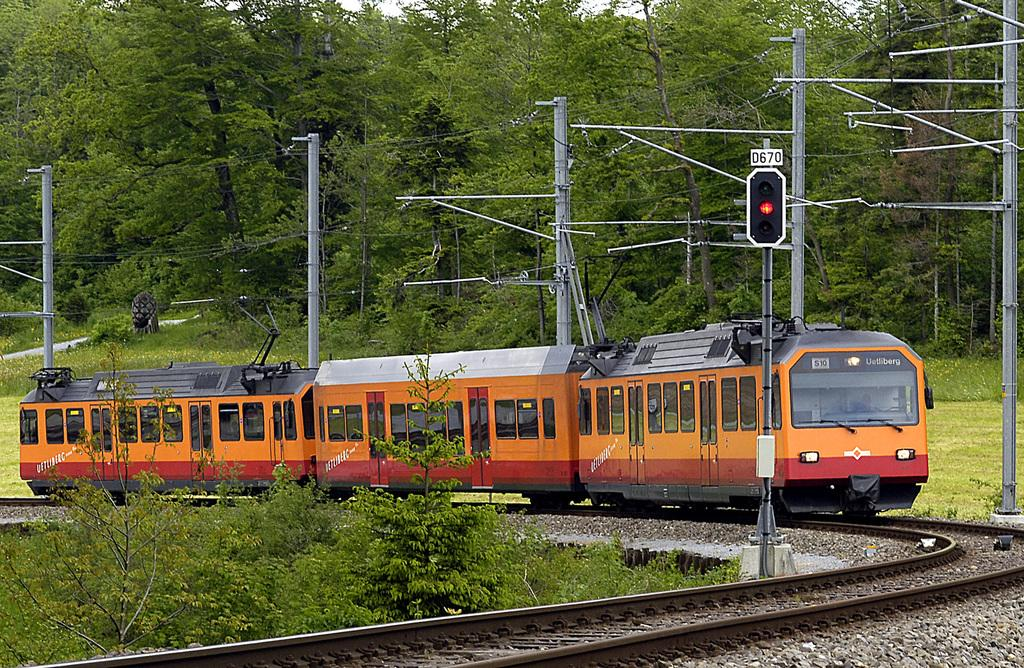What is the main subject of the image? The main subject of the image is a train on the track. What else can be seen in the image besides the train? There are electric poles and cables, trees, flowers, plants, and grass in the image. Can you describe the natural elements in the image? The image includes trees, flowers, plants, and grass. What type of needle can be seen in the image? There is no needle present in the image. Can you describe the ocean in the image? There is no ocean present in the image. 